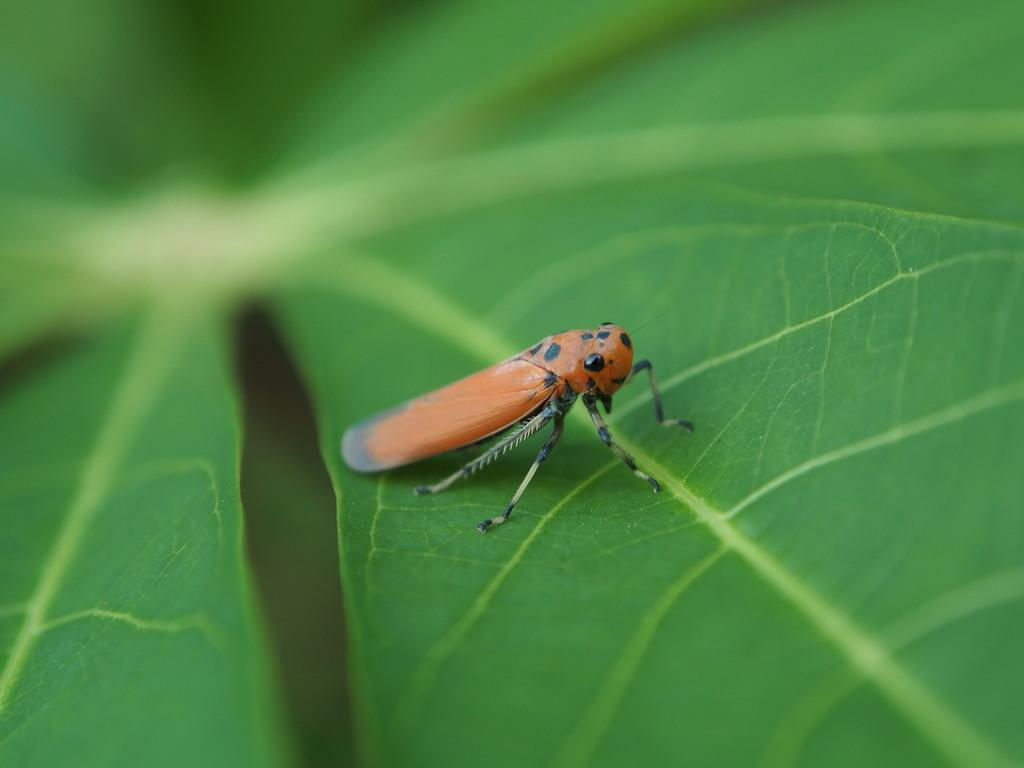What is located in the foreground of the image? There is a leaf in the foreground of the image. What can be seen on the leaf? There is an insect on the leaf. How would you describe the background of the image? The background of the image is blurry. What type of lace is being exchanged between the insect and the leaf in the image? There is no lace or exchange taking place in the image; it features a leaf with an insect on it. 